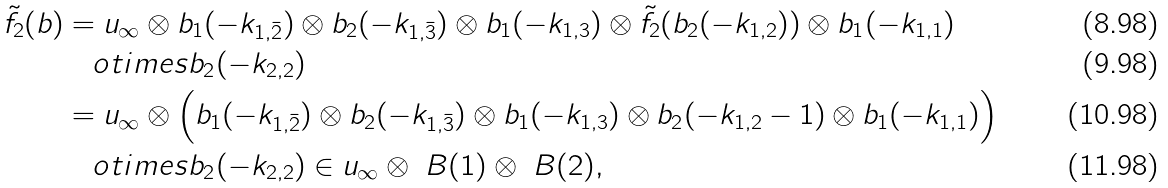<formula> <loc_0><loc_0><loc_500><loc_500>\tilde { f } _ { 2 } ( b ) & = u _ { \infty } \otimes b _ { 1 } ( - k _ { 1 , \bar { 2 } } ) \otimes b _ { 2 } ( - k _ { 1 , \bar { 3 } } ) \otimes b _ { 1 } ( - k _ { 1 , 3 } ) \otimes \tilde { f } _ { 2 } ( b _ { 2 } ( - k _ { 1 , 2 } ) ) \otimes b _ { 1 } ( - k _ { 1 , 1 } ) \\ & \quad o t i m e s b _ { 2 } ( - k _ { 2 , 2 } ) \\ & = u _ { \infty } \otimes \Big { ( } b _ { 1 } ( - k _ { 1 , \bar { 2 } } ) \otimes b _ { 2 } ( - k _ { 1 , \bar { 3 } } ) \otimes b _ { 1 } ( - k _ { 1 , 3 } ) \otimes b _ { 2 } ( - k _ { 1 , 2 } - 1 ) \otimes b _ { 1 } ( - k _ { 1 , 1 } ) \Big { ) } \\ & \quad o t i m e s b _ { 2 } ( - k _ { 2 , 2 } ) \in u _ { \infty } \otimes \ B ( 1 ) \otimes \ B ( 2 ) ,</formula> 